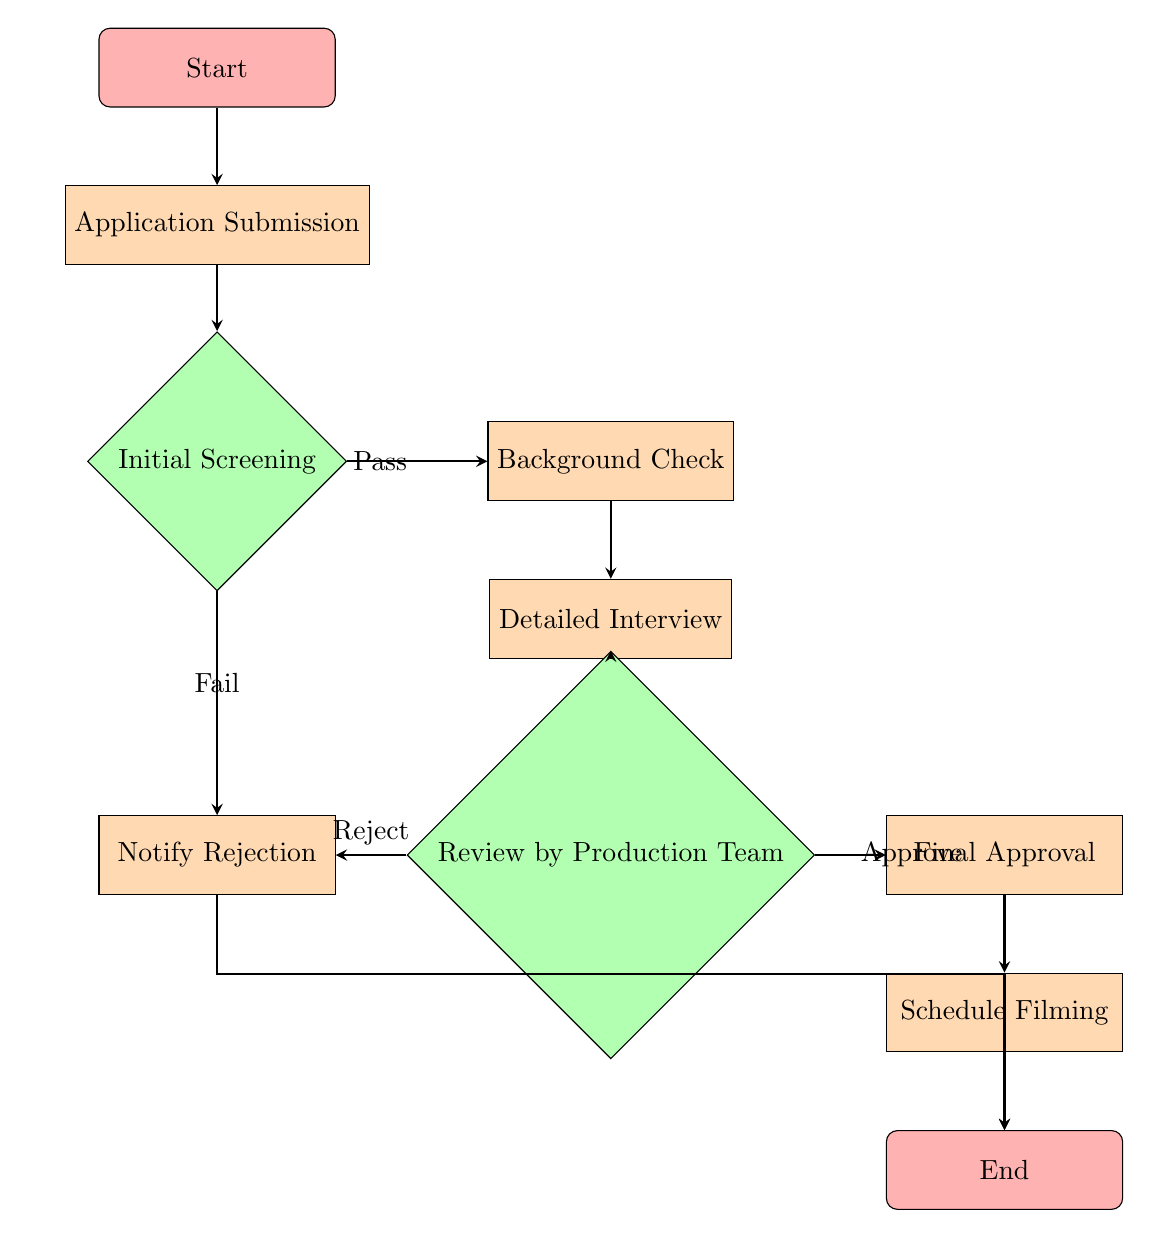What is the first step in the process? The first step is represented as the "Start" node, which indicates the initiation of the application processing flow.
Answer: Start How many decision nodes are in the chart? The chart has two decision nodes: "Initial Screening" and "Review by Production Team."
Answer: 2 What happens if the initial screening fails? If the initial screening fails, the flow leads to the "Notify Rejection" process, indicating a point where candidates are informed of their rejection.
Answer: Notify Rejection What is the final step before ending the process? The final step before reaching the "End" node is "Schedule Filming," which indicates preparation for filming after final approval.
Answer: Schedule Filming If the production team rejects a candidate, what action follows? If the production team rejects a candidate, the flow directs to "Notify Rejection," which notifies the candidate of their status.
Answer: Notify Rejection Which process follows the Background Check? After the Background Check, the next process in the flow is the "Detailed Interview." This shows the progression of the application if the candidate passes the initial screening.
Answer: Detailed Interview What is the consequence of passing the Review by Production Team? Passing the Review leads to "Final Approval," which signifies that the candidate has been approved for filming.
Answer: Final Approval Where does the flow go if the application submission is successful? Upon successful application submission, the flow continues to the "Initial Screening" decision node to determine if the candidate passes or fails.
Answer: Initial Screening 